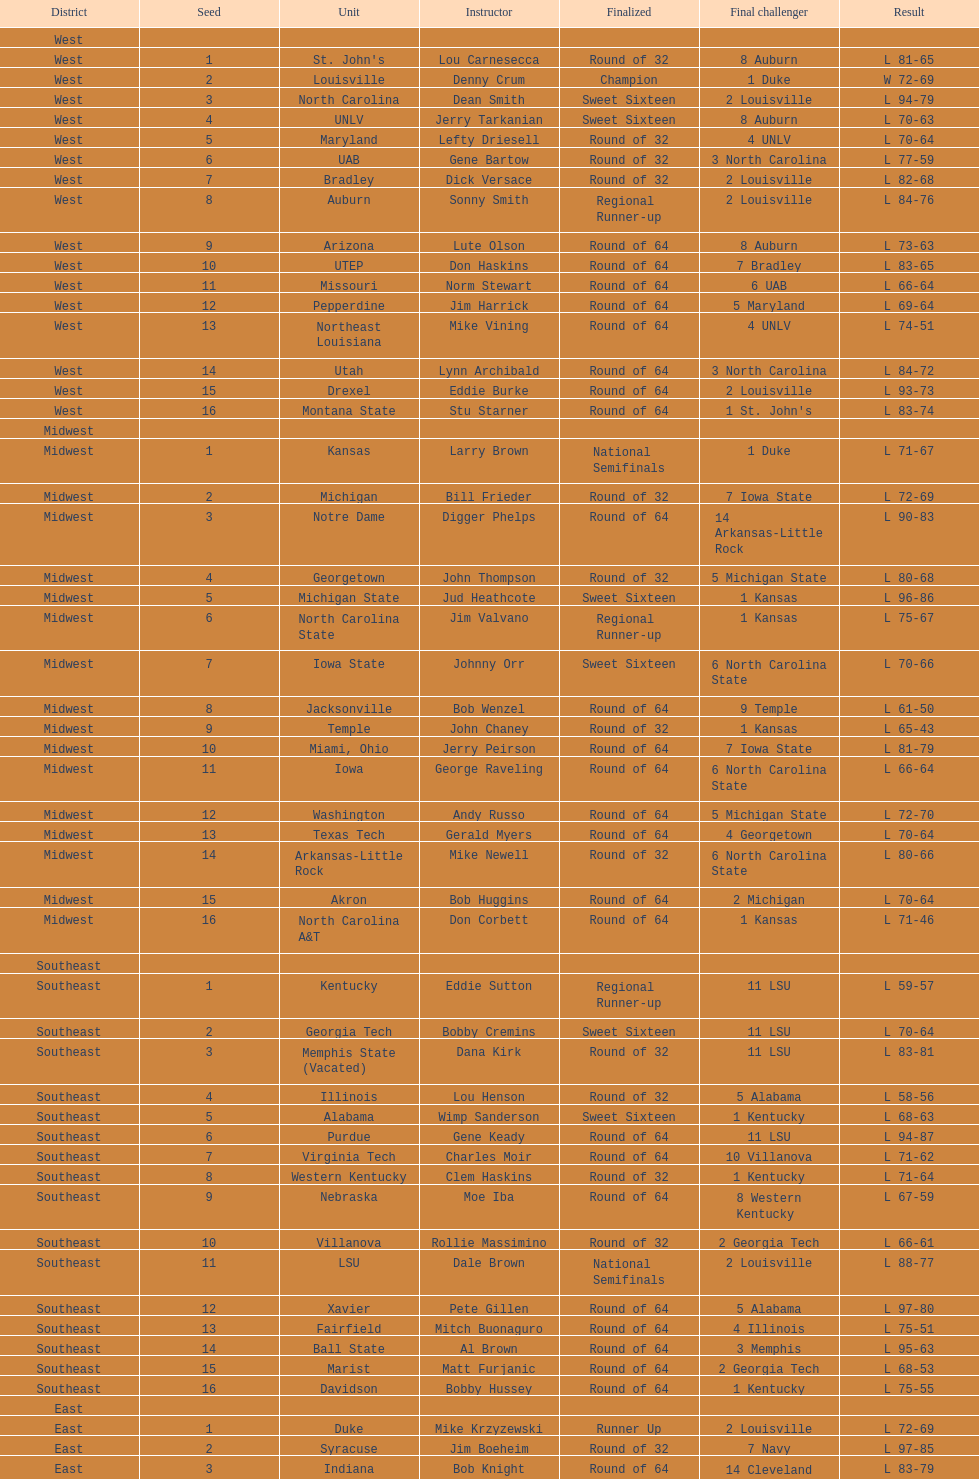How many teams are in the east region. 16. 